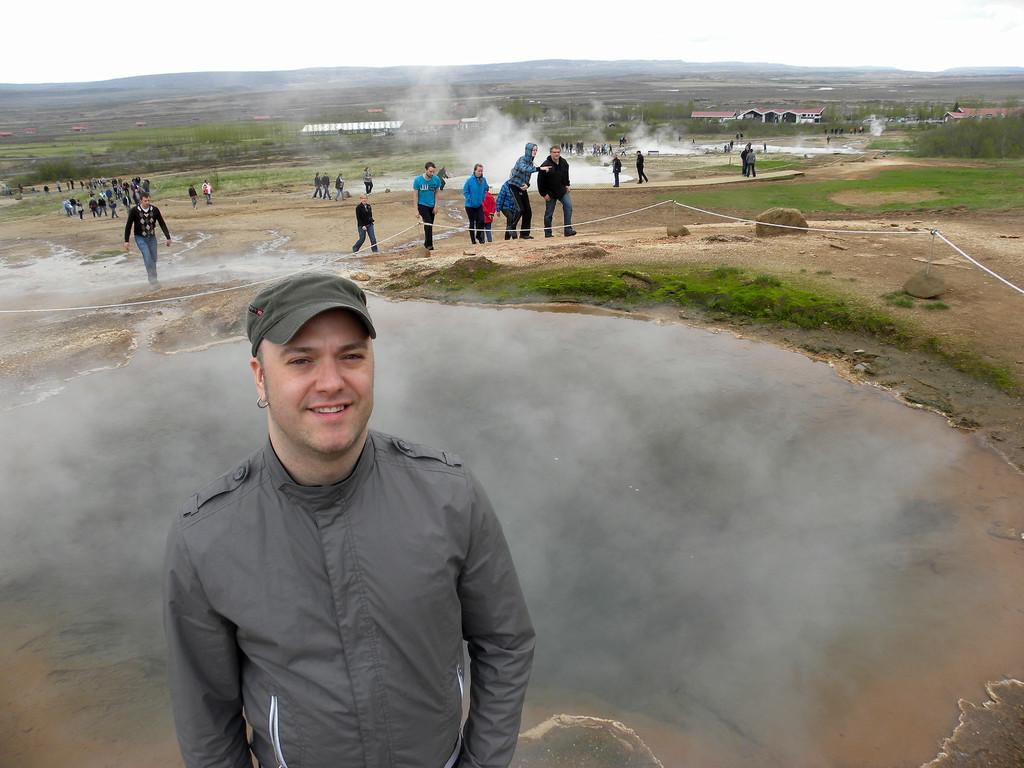What are the people in the image doing? The people in the image are walking on the ground. What can be seen in the background of the image? In the background of the image, there is water, grass, rocks, trees, buildings, and the sky. Can you describe the natural elements visible in the background? The natural elements in the background include grass, rocks, trees, and the sky. What type of cork can be seen floating in the water in the image? There is no cork visible in the image; only water is mentioned in the background. What color is the tub in the image? There is no tub present in the image. 